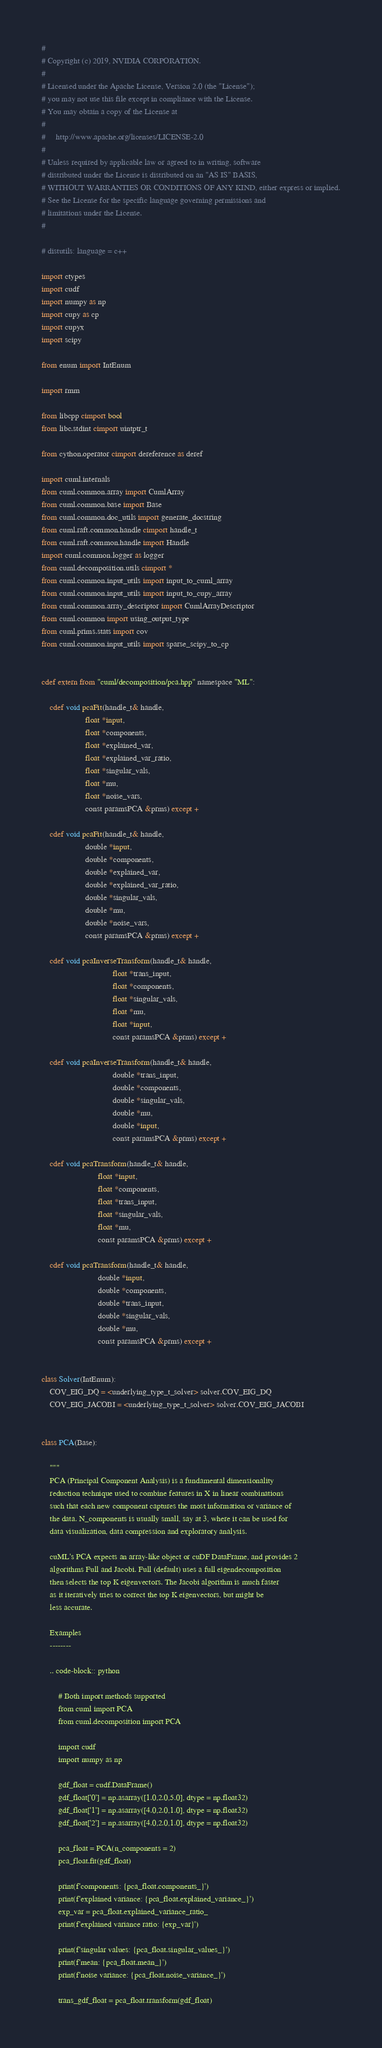<code> <loc_0><loc_0><loc_500><loc_500><_Cython_>#
# Copyright (c) 2019, NVIDIA CORPORATION.
#
# Licensed under the Apache License, Version 2.0 (the "License");
# you may not use this file except in compliance with the License.
# You may obtain a copy of the License at
#
#     http://www.apache.org/licenses/LICENSE-2.0
#
# Unless required by applicable law or agreed to in writing, software
# distributed under the License is distributed on an "AS IS" BASIS,
# WITHOUT WARRANTIES OR CONDITIONS OF ANY KIND, either express or implied.
# See the License for the specific language governing permissions and
# limitations under the License.
#

# distutils: language = c++

import ctypes
import cudf
import numpy as np
import cupy as cp
import cupyx
import scipy

from enum import IntEnum

import rmm

from libcpp cimport bool
from libc.stdint cimport uintptr_t

from cython.operator cimport dereference as deref

import cuml.internals
from cuml.common.array import CumlArray
from cuml.common.base import Base
from cuml.common.doc_utils import generate_docstring
from cuml.raft.common.handle cimport handle_t
from cuml.raft.common.handle import Handle
import cuml.common.logger as logger
from cuml.decomposition.utils cimport *
from cuml.common.input_utils import input_to_cuml_array
from cuml.common.input_utils import input_to_cupy_array
from cuml.common.array_descriptor import CumlArrayDescriptor
from cuml.common import using_output_type
from cuml.prims.stats import cov
from cuml.common.input_utils import sparse_scipy_to_cp


cdef extern from "cuml/decomposition/pca.hpp" namespace "ML":

    cdef void pcaFit(handle_t& handle,
                     float *input,
                     float *components,
                     float *explained_var,
                     float *explained_var_ratio,
                     float *singular_vals,
                     float *mu,
                     float *noise_vars,
                     const paramsPCA &prms) except +

    cdef void pcaFit(handle_t& handle,
                     double *input,
                     double *components,
                     double *explained_var,
                     double *explained_var_ratio,
                     double *singular_vals,
                     double *mu,
                     double *noise_vars,
                     const paramsPCA &prms) except +

    cdef void pcaInverseTransform(handle_t& handle,
                                  float *trans_input,
                                  float *components,
                                  float *singular_vals,
                                  float *mu,
                                  float *input,
                                  const paramsPCA &prms) except +

    cdef void pcaInverseTransform(handle_t& handle,
                                  double *trans_input,
                                  double *components,
                                  double *singular_vals,
                                  double *mu,
                                  double *input,
                                  const paramsPCA &prms) except +

    cdef void pcaTransform(handle_t& handle,
                           float *input,
                           float *components,
                           float *trans_input,
                           float *singular_vals,
                           float *mu,
                           const paramsPCA &prms) except +

    cdef void pcaTransform(handle_t& handle,
                           double *input,
                           double *components,
                           double *trans_input,
                           double *singular_vals,
                           double *mu,
                           const paramsPCA &prms) except +


class Solver(IntEnum):
    COV_EIG_DQ = <underlying_type_t_solver> solver.COV_EIG_DQ
    COV_EIG_JACOBI = <underlying_type_t_solver> solver.COV_EIG_JACOBI


class PCA(Base):

    """
    PCA (Principal Component Analysis) is a fundamental dimensionality
    reduction technique used to combine features in X in linear combinations
    such that each new component captures the most information or variance of
    the data. N_components is usually small, say at 3, where it can be used for
    data visualization, data compression and exploratory analysis.

    cuML's PCA expects an array-like object or cuDF DataFrame, and provides 2
    algorithms Full and Jacobi. Full (default) uses a full eigendecomposition
    then selects the top K eigenvectors. The Jacobi algorithm is much faster
    as it iteratively tries to correct the top K eigenvectors, but might be
    less accurate.

    Examples
    --------

    .. code-block:: python

        # Both import methods supported
        from cuml import PCA
        from cuml.decomposition import PCA

        import cudf
        import numpy as np

        gdf_float = cudf.DataFrame()
        gdf_float['0'] = np.asarray([1.0,2.0,5.0], dtype = np.float32)
        gdf_float['1'] = np.asarray([4.0,2.0,1.0], dtype = np.float32)
        gdf_float['2'] = np.asarray([4.0,2.0,1.0], dtype = np.float32)

        pca_float = PCA(n_components = 2)
        pca_float.fit(gdf_float)

        print(f'components: {pca_float.components_}')
        print(f'explained variance: {pca_float.explained_variance_}')
        exp_var = pca_float.explained_variance_ratio_
        print(f'explained variance ratio: {exp_var}')

        print(f'singular values: {pca_float.singular_values_}')
        print(f'mean: {pca_float.mean_}')
        print(f'noise variance: {pca_float.noise_variance_}')

        trans_gdf_float = pca_float.transform(gdf_float)</code> 